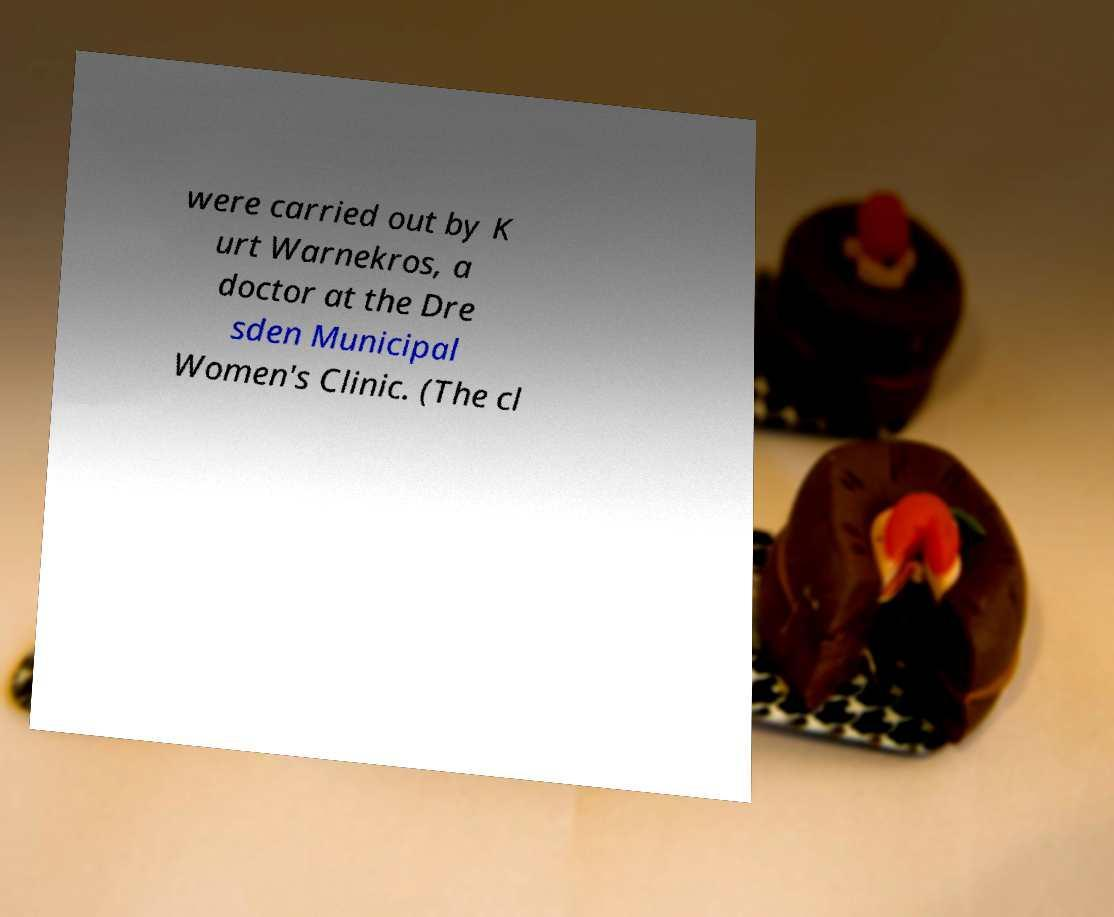Could you extract and type out the text from this image? were carried out by K urt Warnekros, a doctor at the Dre sden Municipal Women's Clinic. (The cl 